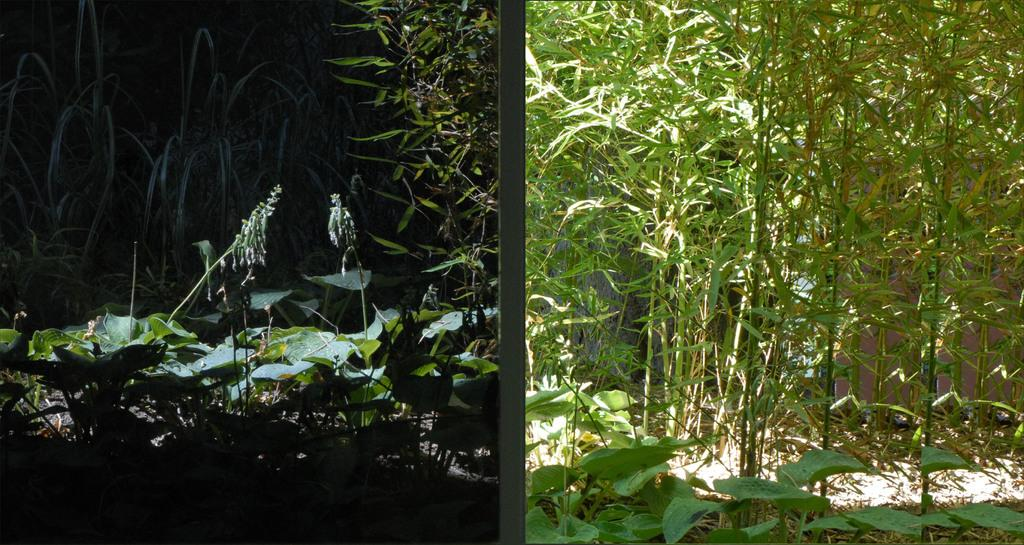What type of artwork is the image? The image is a collage. What elements are included in the collage? There are plants in the image. Where is the crate located in the image? There is no crate present in the image. Can you see a mask in the image? There is no mask present in the image. 